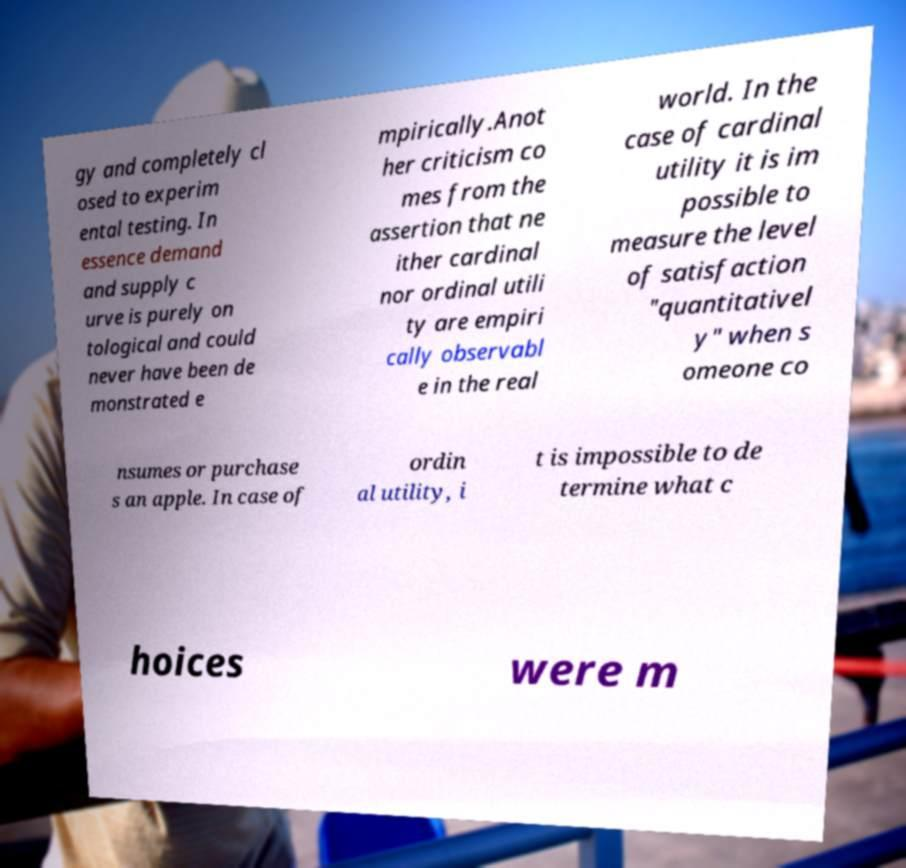What messages or text are displayed in this image? I need them in a readable, typed format. gy and completely cl osed to experim ental testing. In essence demand and supply c urve is purely on tological and could never have been de monstrated e mpirically.Anot her criticism co mes from the assertion that ne ither cardinal nor ordinal utili ty are empiri cally observabl e in the real world. In the case of cardinal utility it is im possible to measure the level of satisfaction "quantitativel y" when s omeone co nsumes or purchase s an apple. In case of ordin al utility, i t is impossible to de termine what c hoices were m 